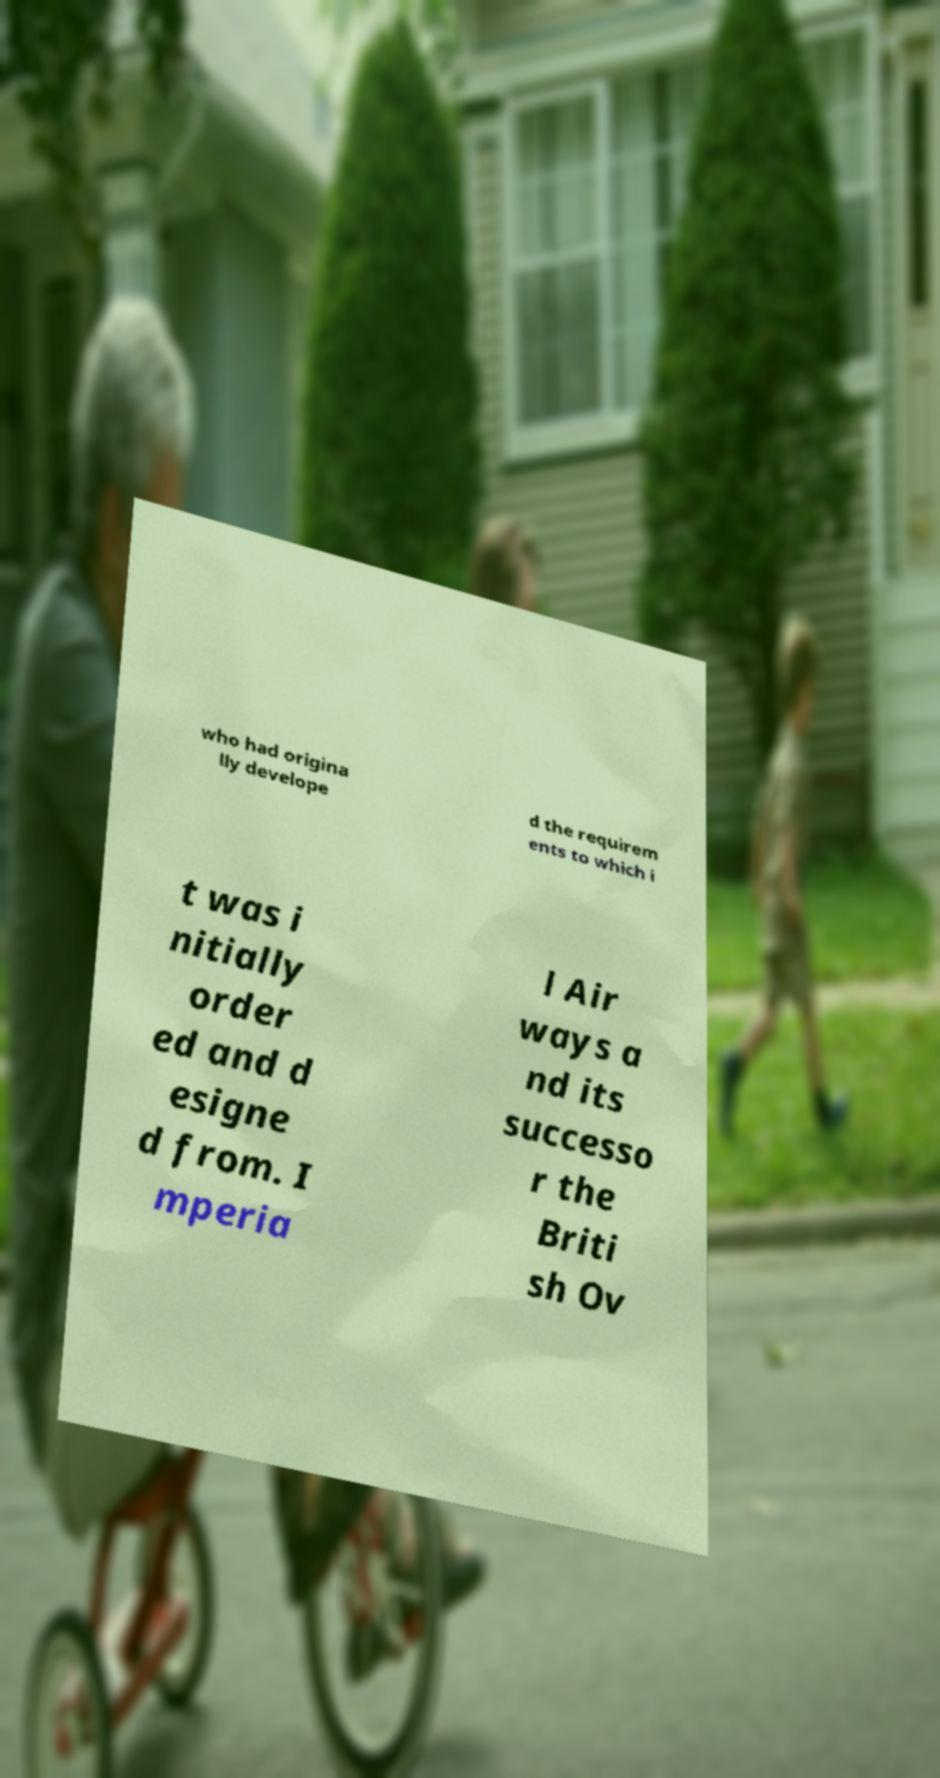Please read and relay the text visible in this image. What does it say? who had origina lly develope d the requirem ents to which i t was i nitially order ed and d esigne d from. I mperia l Air ways a nd its successo r the Briti sh Ov 